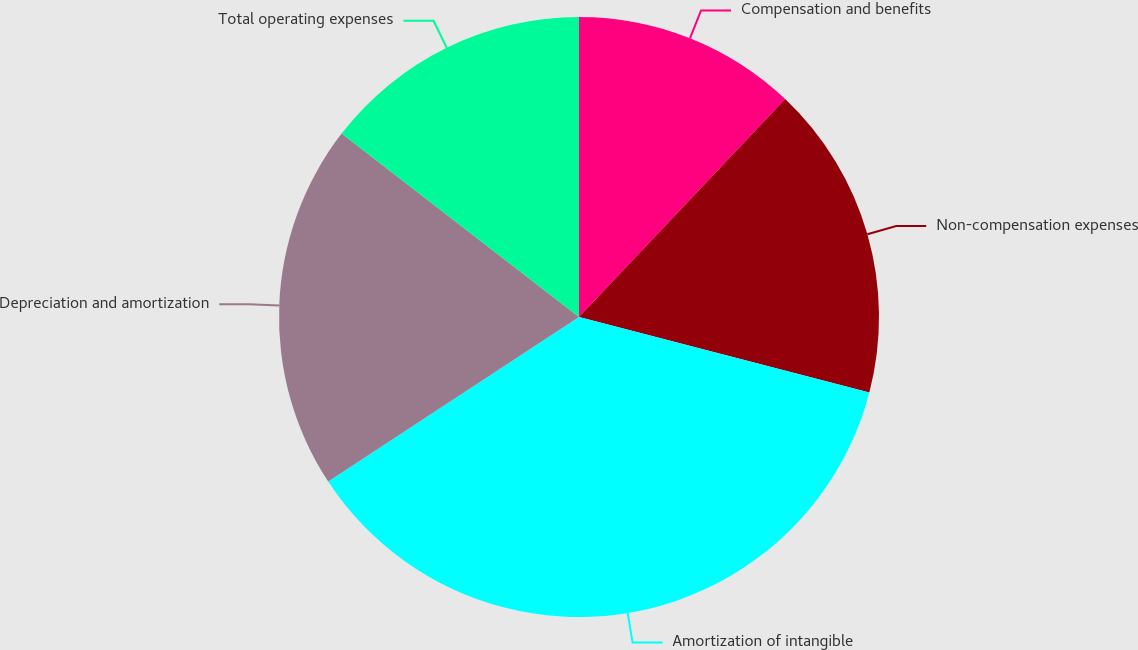<chart> <loc_0><loc_0><loc_500><loc_500><pie_chart><fcel>Compensation and benefits<fcel>Non-compensation expenses<fcel>Amortization of intangible<fcel>Depreciation and amortization<fcel>Total operating expenses<nl><fcel>12.06%<fcel>16.99%<fcel>36.7%<fcel>19.71%<fcel>14.53%<nl></chart> 